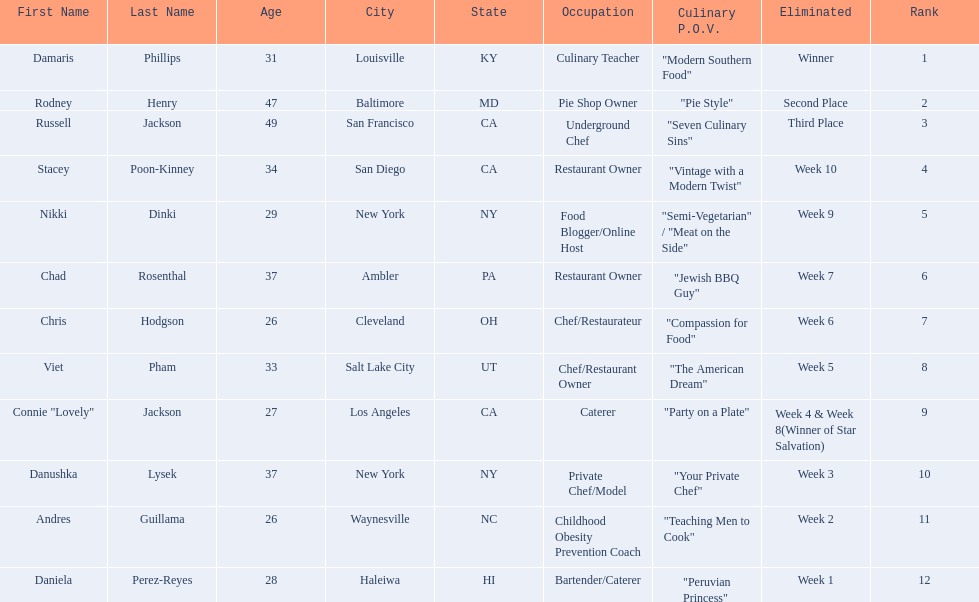Who are all of the contestants? Damaris Phillips, Rodney Henry, Russell Jackson, Stacey Poon-Kinney, Nikki Dinki, Chad Rosenthal, Chris Hodgson, Viet Pham, Connie "Lovely" Jackson, Danushka Lysek, Andres Guillama, Daniela Perez-Reyes. What is each player's culinary point of view? "Modern Southern Food", "Pie Style", "Seven Culinary Sins", "Vintage with a Modern Twist", "Semi-Vegetarian" / "Meat on the Side", "Jewish BBQ Guy", "Compassion for Food", "The American Dream", "Party on a Plate", "Your Private Chef", "Teaching Men to Cook", "Peruvian Princess". And which player's point of view is the longest? Nikki Dinki. 